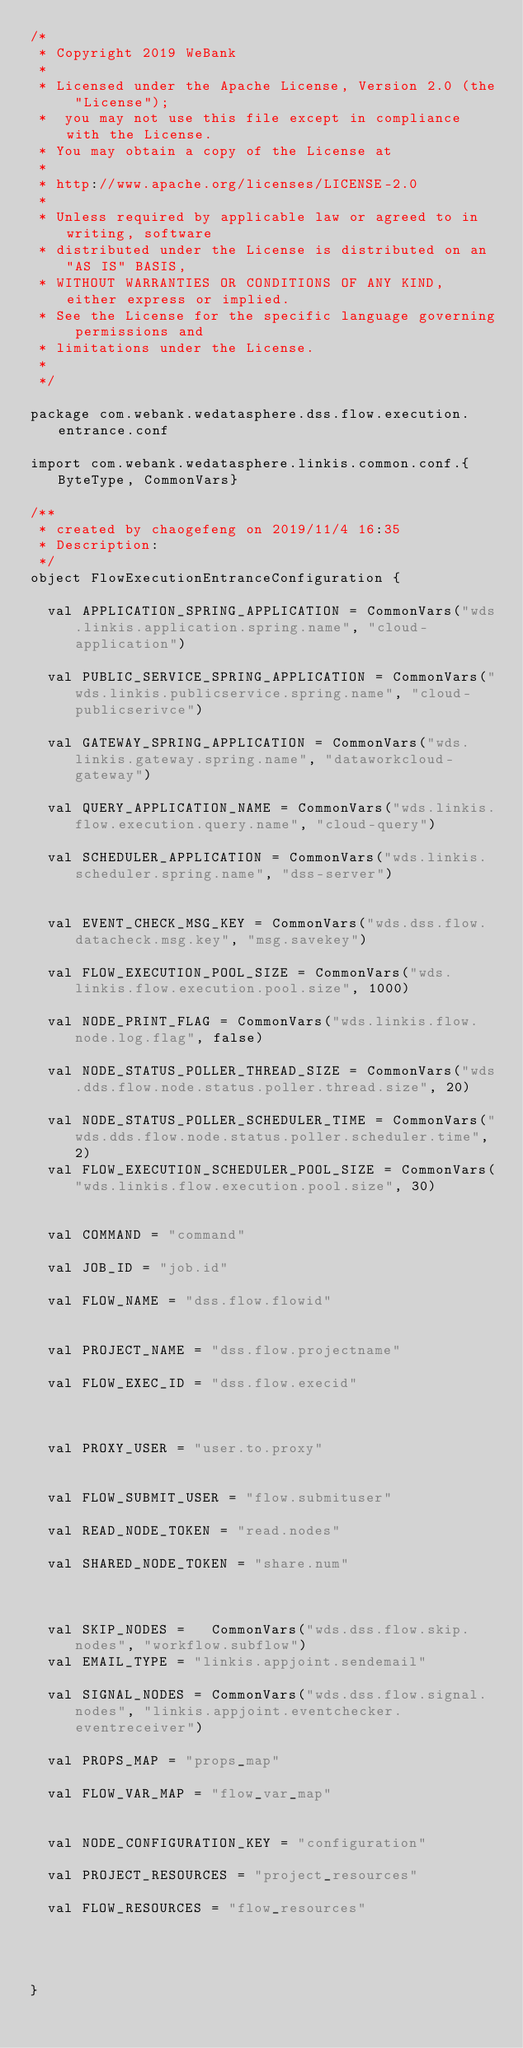Convert code to text. <code><loc_0><loc_0><loc_500><loc_500><_Scala_>/*
 * Copyright 2019 WeBank
 *
 * Licensed under the Apache License, Version 2.0 (the "License");
 *  you may not use this file except in compliance with the License.
 * You may obtain a copy of the License at
 *
 * http://www.apache.org/licenses/LICENSE-2.0
 *
 * Unless required by applicable law or agreed to in writing, software
 * distributed under the License is distributed on an "AS IS" BASIS,
 * WITHOUT WARRANTIES OR CONDITIONS OF ANY KIND, either express or implied.
 * See the License for the specific language governing permissions and
 * limitations under the License.
 *
 */

package com.webank.wedatasphere.dss.flow.execution.entrance.conf

import com.webank.wedatasphere.linkis.common.conf.{ByteType, CommonVars}

/**
 * created by chaogefeng on 2019/11/4 16:35
 * Description:
 */
object FlowExecutionEntranceConfiguration {

  val APPLICATION_SPRING_APPLICATION = CommonVars("wds.linkis.application.spring.name", "cloud-application")

  val PUBLIC_SERVICE_SPRING_APPLICATION = CommonVars("wds.linkis.publicservice.spring.name", "cloud-publicserivce")

  val GATEWAY_SPRING_APPLICATION = CommonVars("wds.linkis.gateway.spring.name", "dataworkcloud-gateway")

  val QUERY_APPLICATION_NAME = CommonVars("wds.linkis.flow.execution.query.name", "cloud-query")

  val SCHEDULER_APPLICATION = CommonVars("wds.linkis.scheduler.spring.name", "dss-server")


  val EVENT_CHECK_MSG_KEY = CommonVars("wds.dss.flow.datacheck.msg.key", "msg.savekey")

  val FLOW_EXECUTION_POOL_SIZE = CommonVars("wds.linkis.flow.execution.pool.size", 1000)

  val NODE_PRINT_FLAG = CommonVars("wds.linkis.flow.node.log.flag", false)

  val NODE_STATUS_POLLER_THREAD_SIZE = CommonVars("wds.dds.flow.node.status.poller.thread.size", 20)

  val NODE_STATUS_POLLER_SCHEDULER_TIME = CommonVars("wds.dds.flow.node.status.poller.scheduler.time", 2)
  val FLOW_EXECUTION_SCHEDULER_POOL_SIZE = CommonVars("wds.linkis.flow.execution.pool.size", 30)


  val COMMAND = "command"

  val JOB_ID = "job.id"

  val FLOW_NAME = "dss.flow.flowid"


  val PROJECT_NAME = "dss.flow.projectname"

  val FLOW_EXEC_ID = "dss.flow.execid"



  val PROXY_USER = "user.to.proxy"


  val FLOW_SUBMIT_USER = "flow.submituser"

  val READ_NODE_TOKEN = "read.nodes"

  val SHARED_NODE_TOKEN = "share.num"



  val SKIP_NODES =   CommonVars("wds.dss.flow.skip.nodes", "workflow.subflow")
  val EMAIL_TYPE = "linkis.appjoint.sendemail"

  val SIGNAL_NODES = CommonVars("wds.dss.flow.signal.nodes", "linkis.appjoint.eventchecker.eventreceiver")

  val PROPS_MAP = "props_map"

  val FLOW_VAR_MAP = "flow_var_map"


  val NODE_CONFIGURATION_KEY = "configuration"

  val PROJECT_RESOURCES = "project_resources"

  val FLOW_RESOURCES = "flow_resources"




}
</code> 